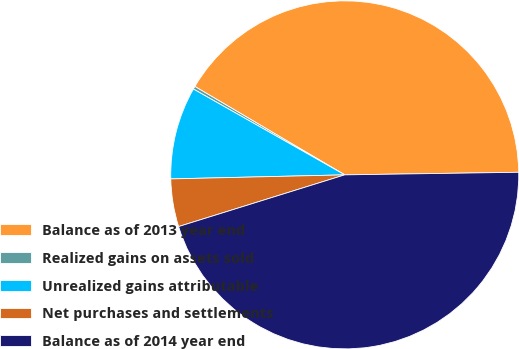Convert chart to OTSL. <chart><loc_0><loc_0><loc_500><loc_500><pie_chart><fcel>Balance as of 2013 year end<fcel>Realized gains on assets sold<fcel>Unrealized gains attributable<fcel>Net purchases and settlements<fcel>Balance as of 2014 year end<nl><fcel>41.28%<fcel>0.27%<fcel>8.58%<fcel>4.43%<fcel>45.43%<nl></chart> 